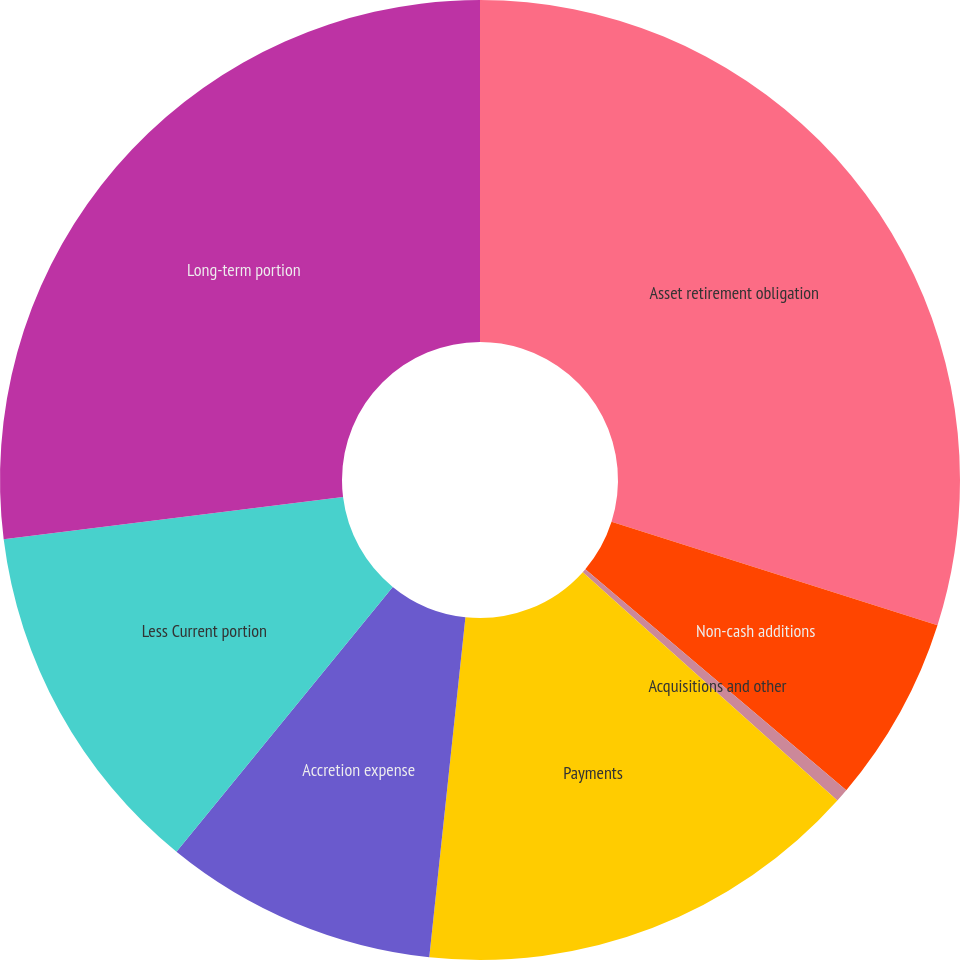Convert chart to OTSL. <chart><loc_0><loc_0><loc_500><loc_500><pie_chart><fcel>Asset retirement obligation<fcel>Non-cash additions<fcel>Acquisitions and other<fcel>Payments<fcel>Accretion expense<fcel>Less Current portion<fcel>Long-term portion<nl><fcel>29.89%<fcel>6.29%<fcel>0.45%<fcel>15.05%<fcel>9.21%<fcel>12.13%<fcel>26.97%<nl></chart> 